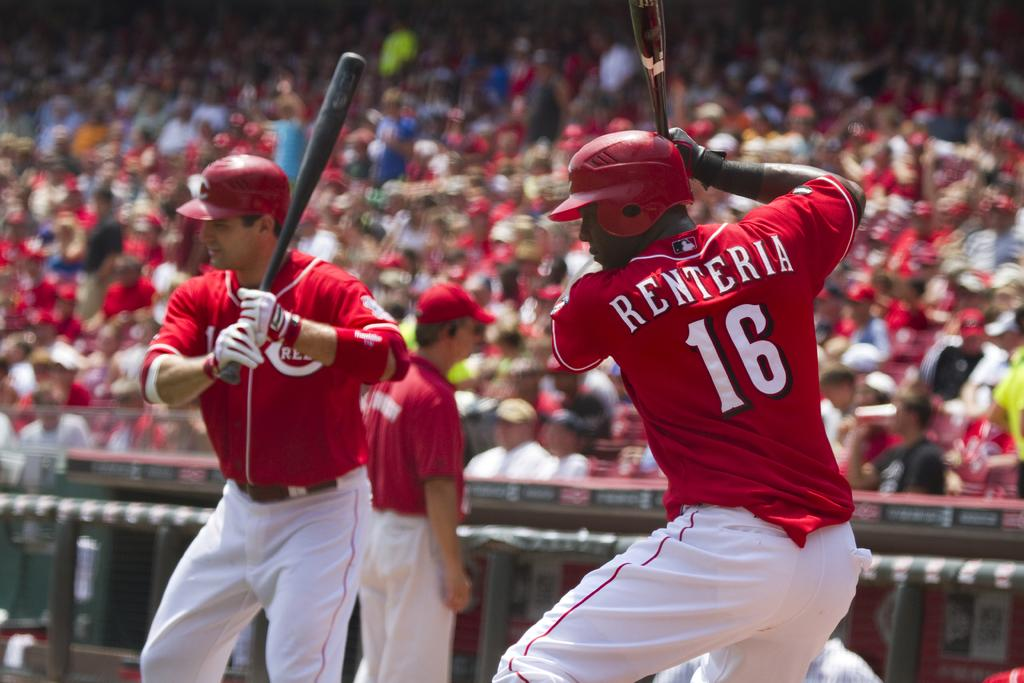<image>
Render a clear and concise summary of the photo. Renteria number 16 is getting in his practice swings. 